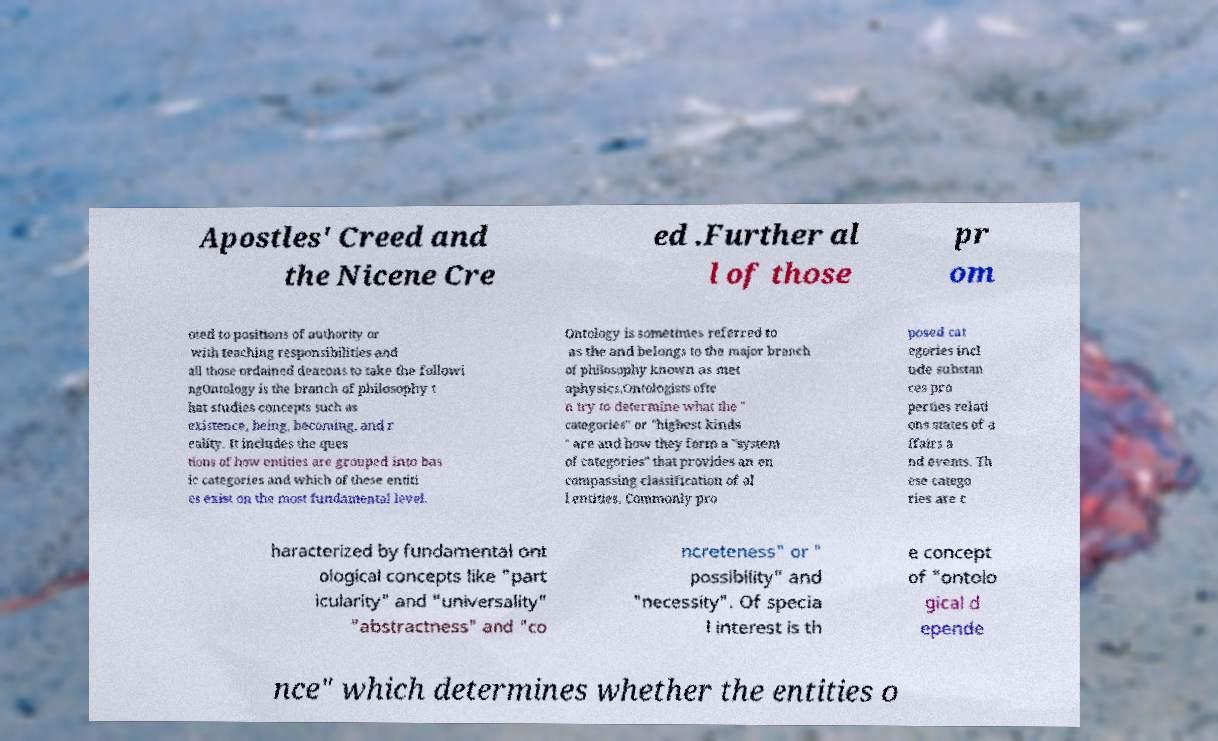Can you read and provide the text displayed in the image?This photo seems to have some interesting text. Can you extract and type it out for me? Apostles' Creed and the Nicene Cre ed .Further al l of those pr om oted to positions of authority or with teaching responsibilities and all those ordained deacons to take the followi ngOntology is the branch of philosophy t hat studies concepts such as existence, being, becoming, and r eality. It includes the ques tions of how entities are grouped into bas ic categories and which of these entiti es exist on the most fundamental level. Ontology is sometimes referred to as the and belongs to the major branch of philosophy known as met aphysics.Ontologists ofte n try to determine what the " categories" or "highest kinds " are and how they form a "system of categories" that provides an en compassing classification of al l entities. Commonly pro posed cat egories incl ude substan ces pro perties relati ons states of a ffairs a nd events. Th ese catego ries are c haracterized by fundamental ont ological concepts like "part icularity" and "universality" "abstractness" and "co ncreteness" or " possibility" and "necessity". Of specia l interest is th e concept of "ontolo gical d epende nce" which determines whether the entities o 